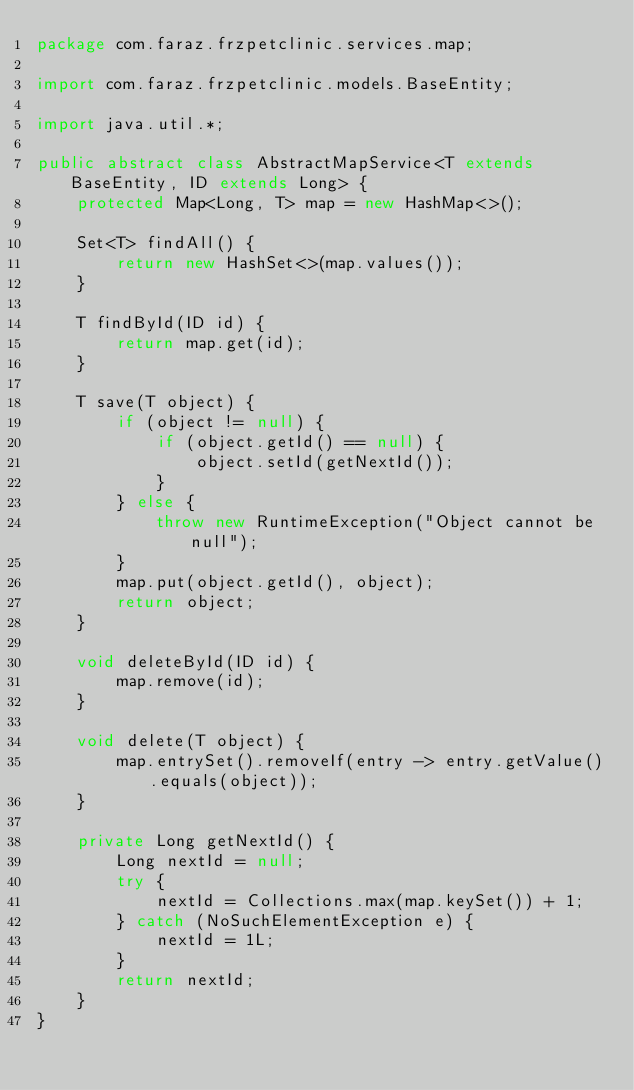Convert code to text. <code><loc_0><loc_0><loc_500><loc_500><_Java_>package com.faraz.frzpetclinic.services.map;

import com.faraz.frzpetclinic.models.BaseEntity;

import java.util.*;

public abstract class AbstractMapService<T extends BaseEntity, ID extends Long> {
    protected Map<Long, T> map = new HashMap<>();

    Set<T> findAll() {
        return new HashSet<>(map.values());
    }

    T findById(ID id) {
        return map.get(id);
    }

    T save(T object) {
        if (object != null) {
            if (object.getId() == null) {
                object.setId(getNextId());
            }
        } else {
            throw new RuntimeException("Object cannot be null");
        }
        map.put(object.getId(), object);
        return object;
    }

    void deleteById(ID id) {
        map.remove(id);
    }

    void delete(T object) {
        map.entrySet().removeIf(entry -> entry.getValue().equals(object));
    }

    private Long getNextId() {
        Long nextId = null;
        try {
            nextId = Collections.max(map.keySet()) + 1;
        } catch (NoSuchElementException e) {
            nextId = 1L;
        }
        return nextId;
    }
}
</code> 